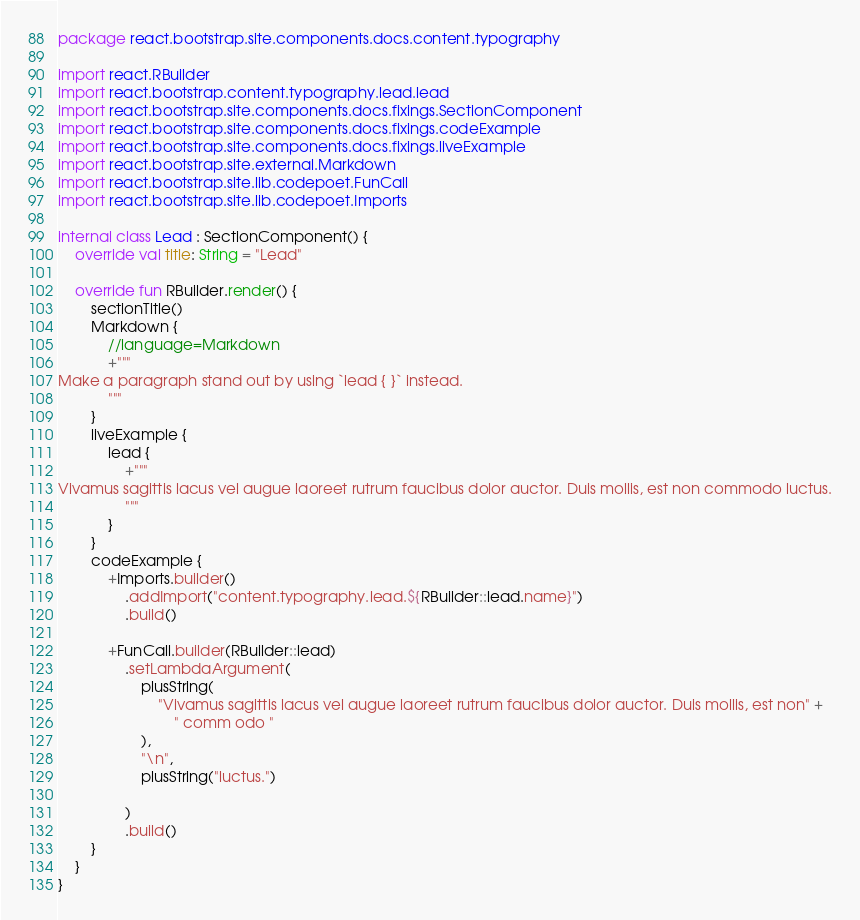Convert code to text. <code><loc_0><loc_0><loc_500><loc_500><_Kotlin_>package react.bootstrap.site.components.docs.content.typography

import react.RBuilder
import react.bootstrap.content.typography.lead.lead
import react.bootstrap.site.components.docs.fixings.SectionComponent
import react.bootstrap.site.components.docs.fixings.codeExample
import react.bootstrap.site.components.docs.fixings.liveExample
import react.bootstrap.site.external.Markdown
import react.bootstrap.site.lib.codepoet.FunCall
import react.bootstrap.site.lib.codepoet.Imports

internal class Lead : SectionComponent() {
    override val title: String = "Lead"

    override fun RBuilder.render() {
        sectionTitle()
        Markdown {
            //language=Markdown
            +"""
Make a paragraph stand out by using `lead { }` instead.
            """
        }
        liveExample {
            lead {
                +"""
Vivamus sagittis lacus vel augue laoreet rutrum faucibus dolor auctor. Duis mollis, est non commodo luctus.
                """
            }
        }
        codeExample {
            +Imports.builder()
                .addImport("content.typography.lead.${RBuilder::lead.name}")
                .build()

            +FunCall.builder(RBuilder::lead)
                .setLambdaArgument(
                    plusString(
                        "Vivamus sagittis lacus vel augue laoreet rutrum faucibus dolor auctor. Duis mollis, est non" +
                            " comm odo "
                    ),
                    "\n",
                    plusString("luctus.")

                )
                .build()
        }
    }
}
</code> 